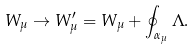<formula> <loc_0><loc_0><loc_500><loc_500>W _ { \mu } \rightarrow W _ { \mu } ^ { \prime } = W _ { \mu } + \oint _ { \alpha _ { \mu } } \Lambda .</formula> 